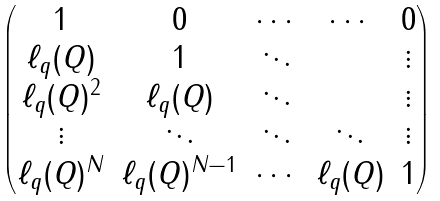Convert formula to latex. <formula><loc_0><loc_0><loc_500><loc_500>\begin{pmatrix} 1 & 0 & \cdots & \cdots & 0 \\ \ell _ { q } ( Q ) & 1 & \ddots & & \vdots \\ \ell _ { q } ( Q ) ^ { 2 } & \ell _ { q } ( Q ) & \ddots & & \vdots \\ \vdots & \ddots & \ddots & \ddots & \vdots \\ \ell _ { q } ( Q ) ^ { N } & \ell _ { q } ( Q ) ^ { N - 1 } & \cdots & \ell _ { q } ( Q ) & 1 \end{pmatrix}</formula> 